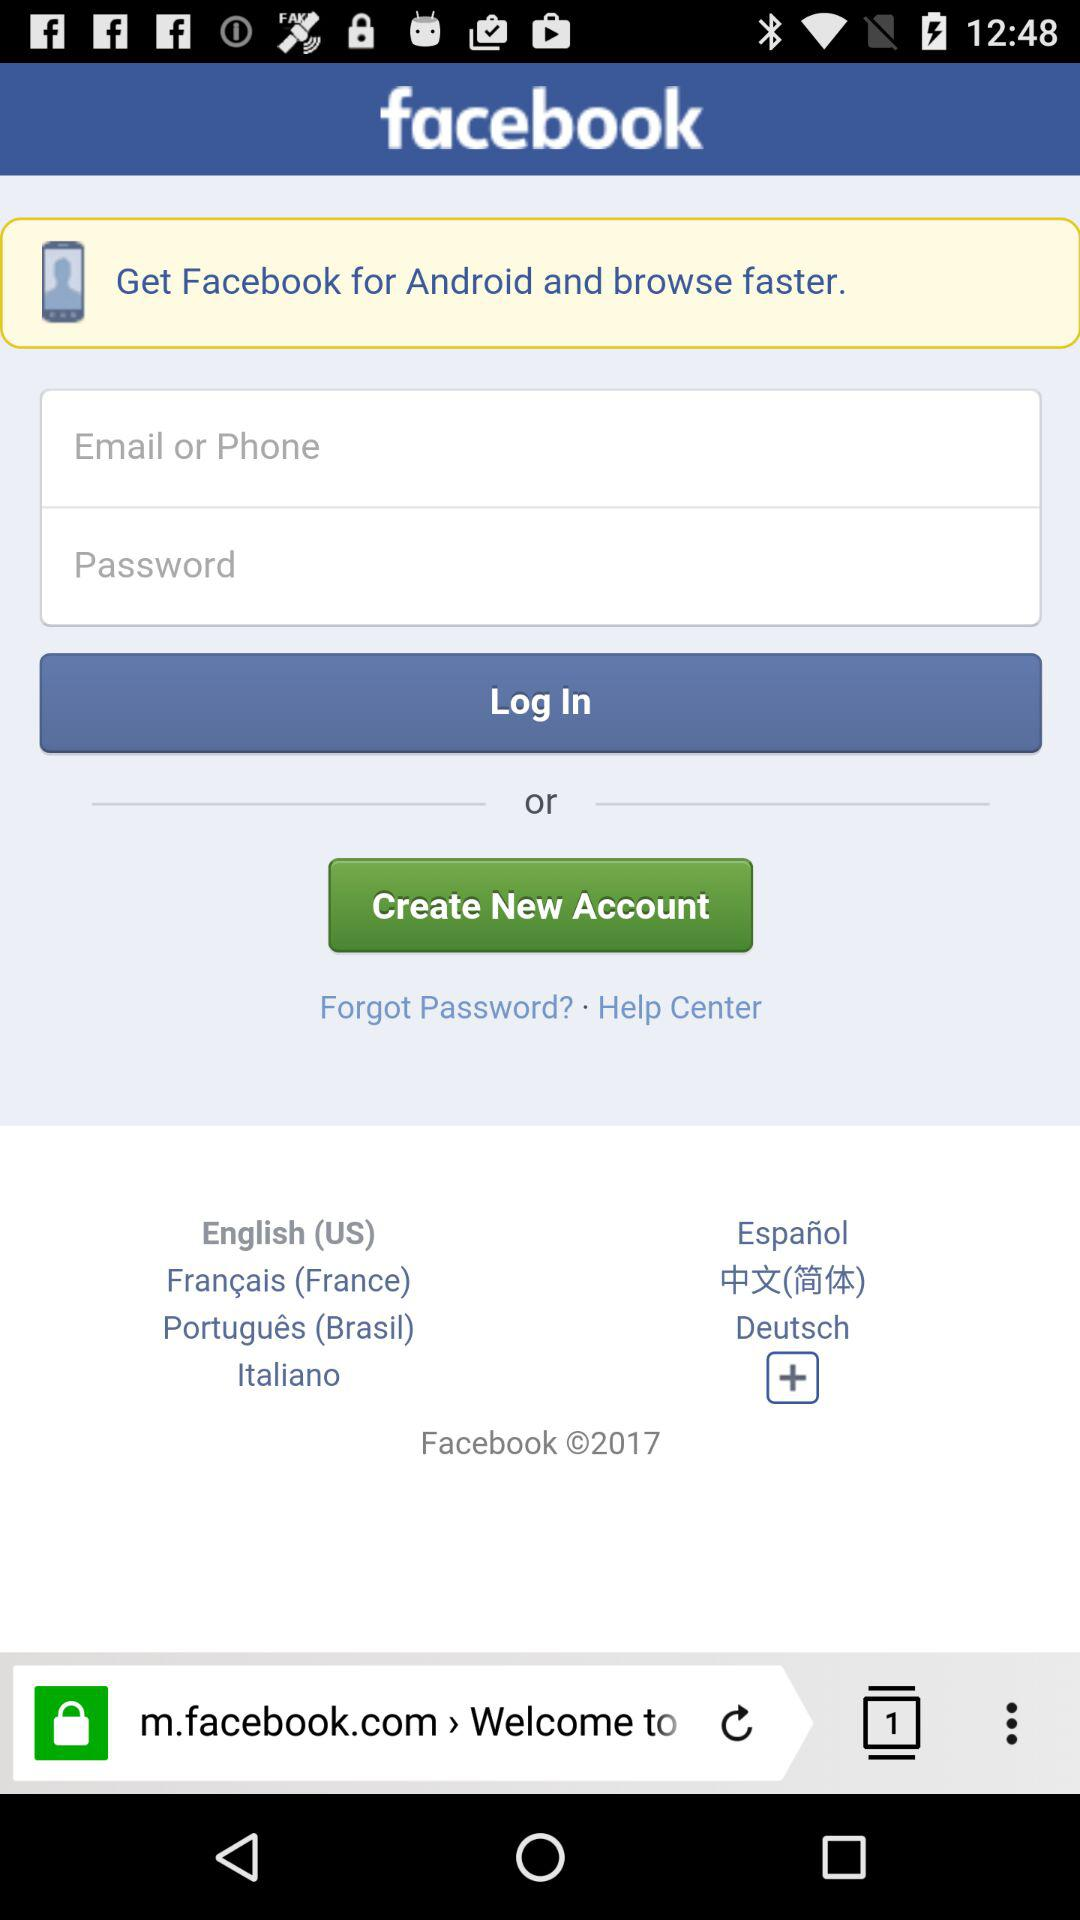What is the name of the application? The name of the application is "facebook". 